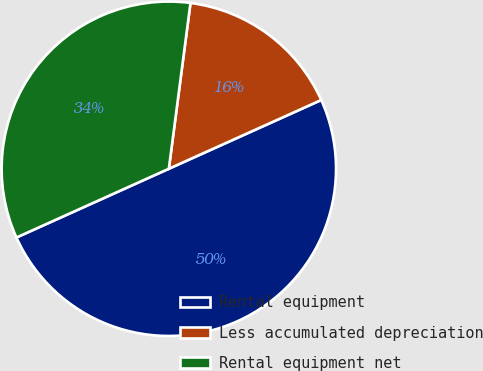Convert chart. <chart><loc_0><loc_0><loc_500><loc_500><pie_chart><fcel>Rental equipment<fcel>Less accumulated depreciation<fcel>Rental equipment net<nl><fcel>50.0%<fcel>16.19%<fcel>33.81%<nl></chart> 